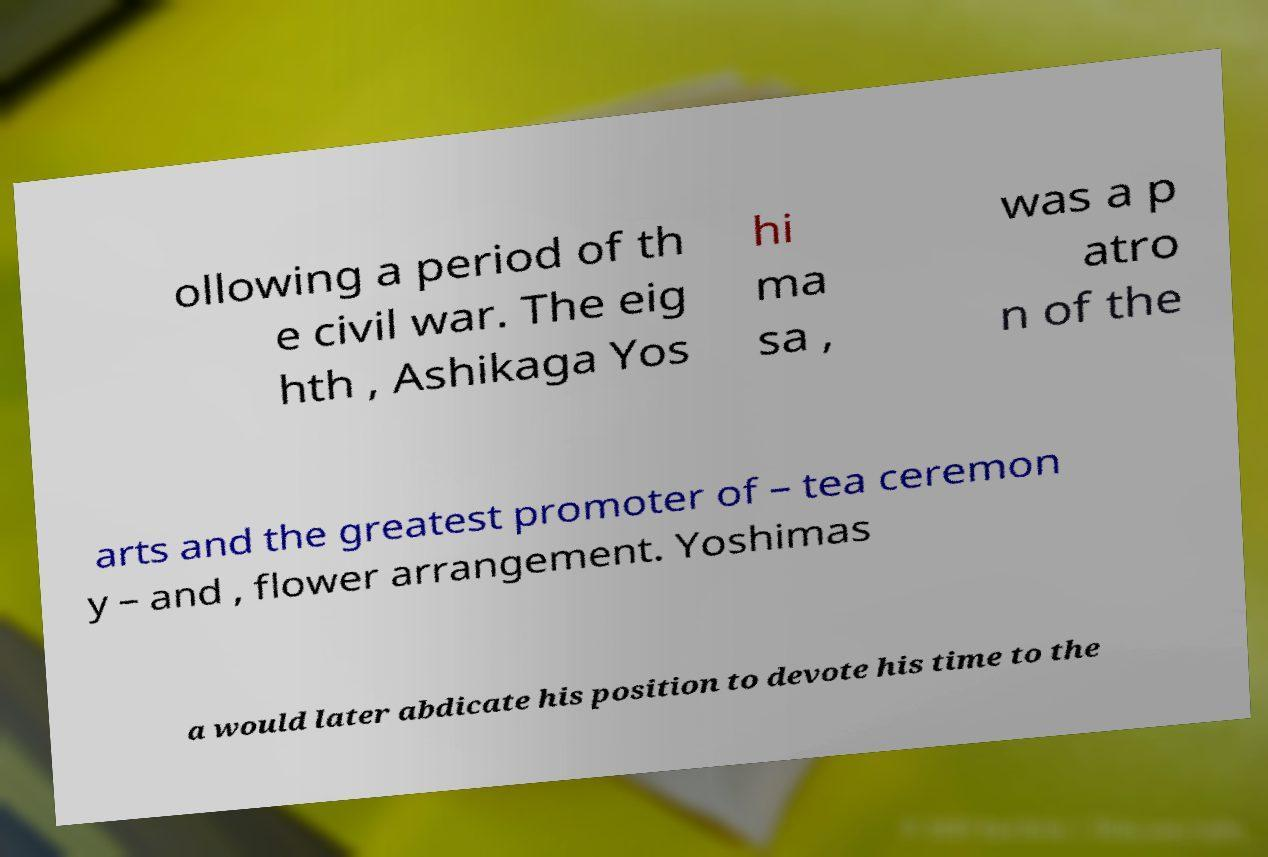Please identify and transcribe the text found in this image. ollowing a period of th e civil war. The eig hth , Ashikaga Yos hi ma sa , was a p atro n of the arts and the greatest promoter of – tea ceremon y – and , flower arrangement. Yoshimas a would later abdicate his position to devote his time to the 